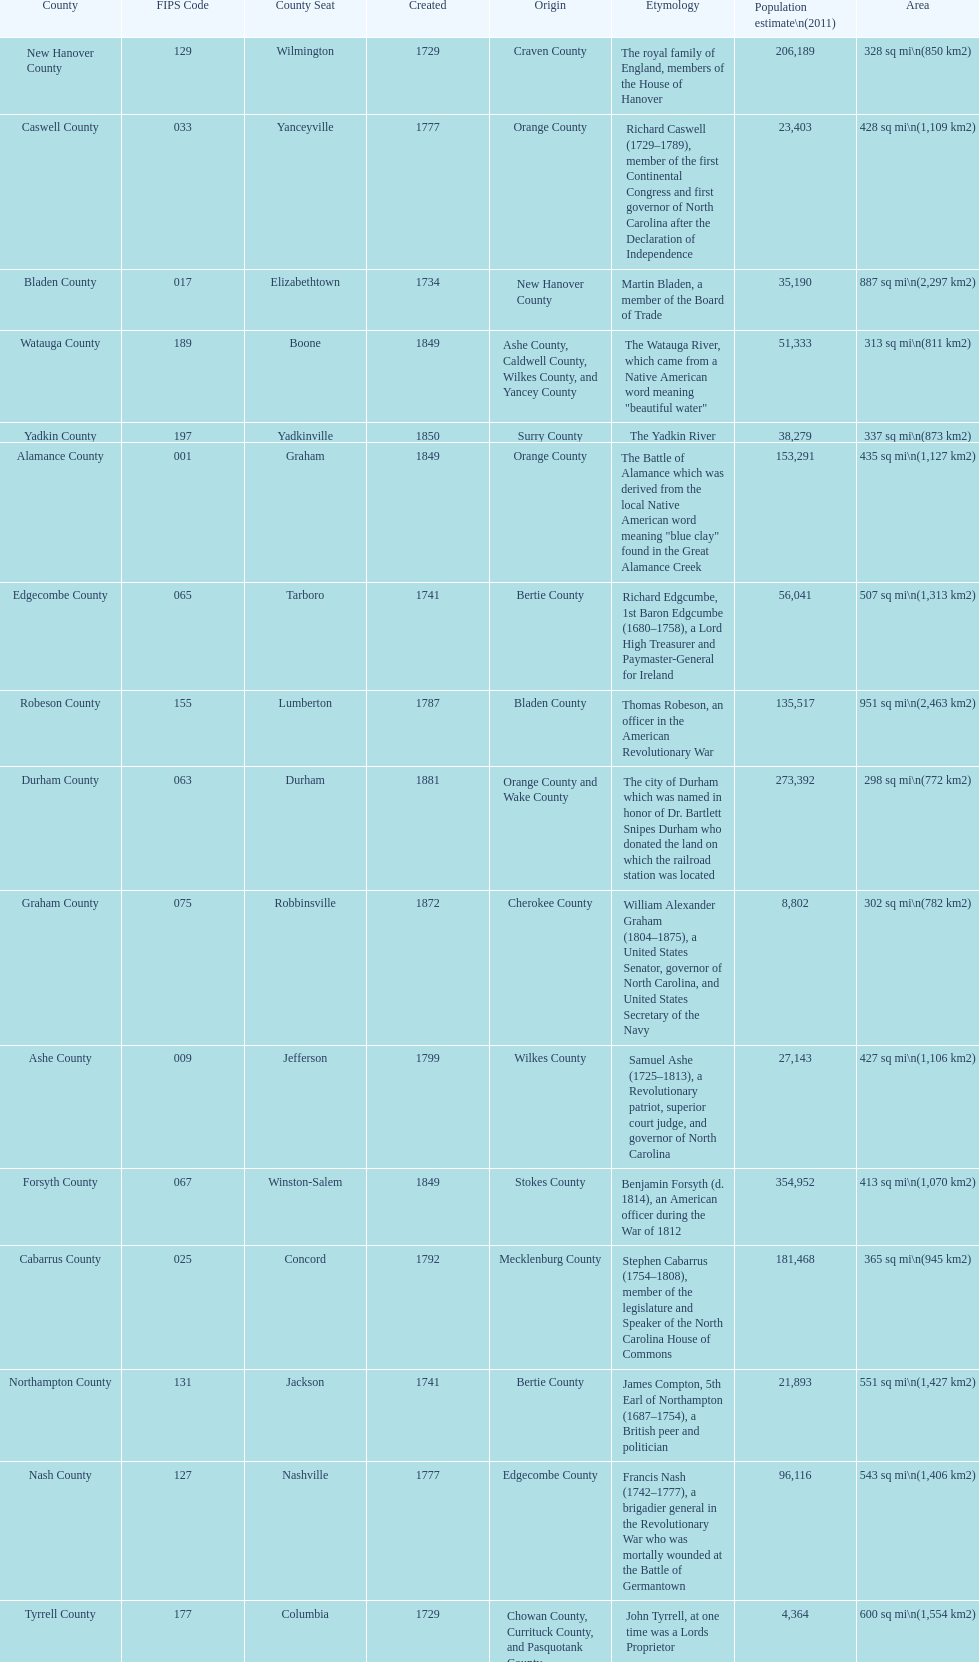What number of counties are named for us presidents? 3. 